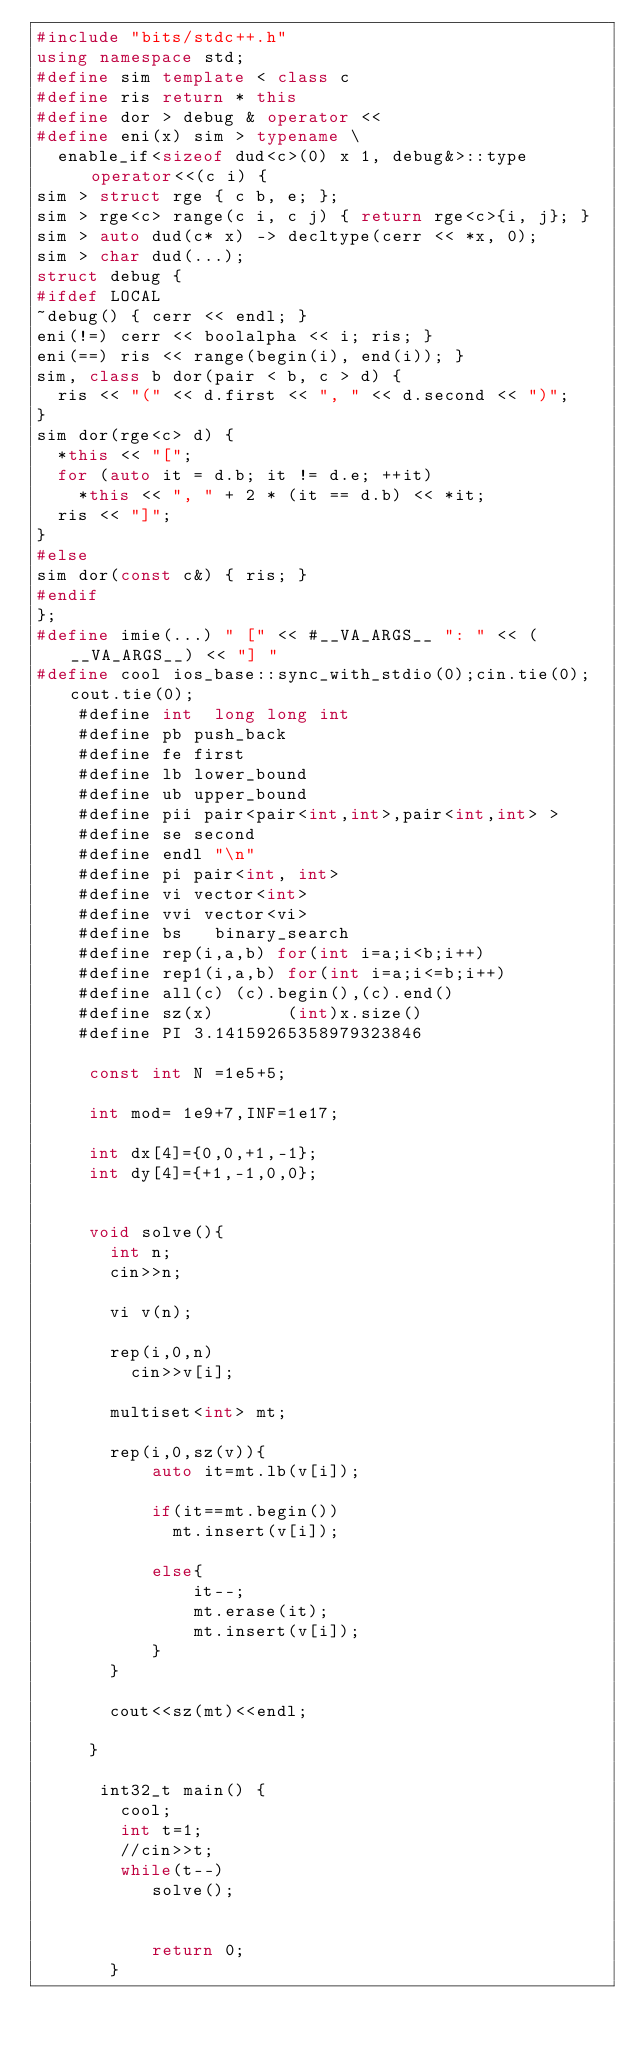Convert code to text. <code><loc_0><loc_0><loc_500><loc_500><_C++_>#include "bits/stdc++.h"
using namespace std;
#define sim template < class c
#define ris return * this
#define dor > debug & operator <<
#define eni(x) sim > typename \
  enable_if<sizeof dud<c>(0) x 1, debug&>::type operator<<(c i) {
sim > struct rge { c b, e; };
sim > rge<c> range(c i, c j) { return rge<c>{i, j}; }
sim > auto dud(c* x) -> decltype(cerr << *x, 0);
sim > char dud(...);
struct debug {
#ifdef LOCAL
~debug() { cerr << endl; }
eni(!=) cerr << boolalpha << i; ris; }
eni(==) ris << range(begin(i), end(i)); }
sim, class b dor(pair < b, c > d) {
  ris << "(" << d.first << ", " << d.second << ")";
}
sim dor(rge<c> d) {
  *this << "[";
  for (auto it = d.b; it != d.e; ++it)
    *this << ", " + 2 * (it == d.b) << *it;
  ris << "]";
}
#else
sim dor(const c&) { ris; }
#endif
};
#define imie(...) " [" << #__VA_ARGS__ ": " << (__VA_ARGS__) << "] "
#define cool ios_base::sync_with_stdio(0);cin.tie(0);cout.tie(0);
	#define int  long long int
	#define pb push_back
	#define fe first
    #define lb lower_bound 
    #define ub upper_bound
    #define pii pair<pair<int,int>,pair<int,int> >
	#define se second
	#define endl "\n"
	#define pi pair<int, int>
	#define vi vector<int> 
	#define vvi vector<vi>
    #define bs   binary_search
	#define rep(i,a,b) for(int i=a;i<b;i++)
	#define rep1(i,a,b) for(int i=a;i<=b;i++)	
    #define all(c) (c).begin(),(c).end()
    #define sz(x)       (int)x.size() 
	#define PI 3.14159265358979323846
    
	 const int N =1e5+5;
    
     int mod= 1e9+7,INF=1e17;
     
     int dx[4]={0,0,+1,-1};
     int dy[4]={+1,-1,0,0};
 
     
     void solve(){
       int n;
       cin>>n;
       
       vi v(n);
       
       rep(i,0,n)
         cin>>v[i];    
       
       multiset<int> mt;
       
       rep(i,0,sz(v)){
		   auto it=mt.lb(v[i]);
		   
		   if(it==mt.begin())
		     mt.insert(v[i]);
		   
		   else{
			   it--;
			   mt.erase(it);
			   mt.insert(v[i]); 
		   }	   
	   }
	   
	   cout<<sz(mt)<<endl;  
               
	 }
	
      int32_t main() {
	    cool;
	    int t=1;
        //cin>>t;
	    while(t--)
	       solve();
	       
	       
	       return 0;	   
	   }
</code> 